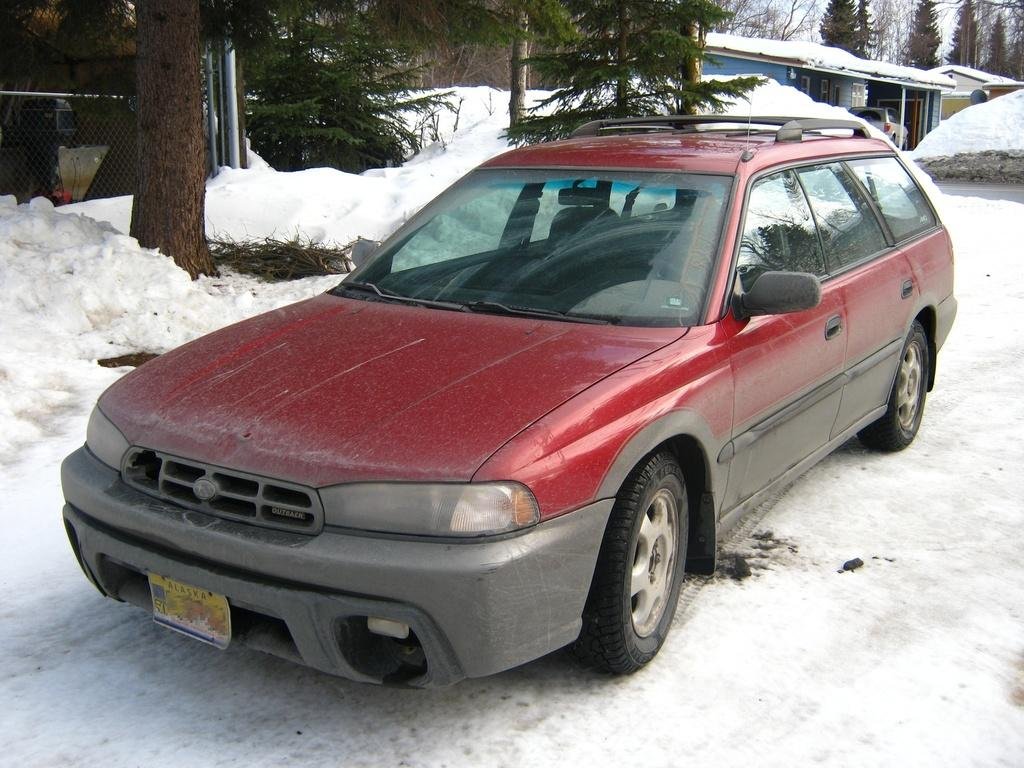What is the main subject in the foreground of the image? There is a car in the foreground of the image. What is the condition of the ground in the foreground? There is snow in the foreground of the image. What can be seen towards the left side of the image? There are trees and snow towards the left side of the image, as well as fencing. What can be seen towards the right side of the image? There are trees, a building, a car, snow, a road, and sky visible towards the right side of the image. What type of flesh can be seen hanging from the trees in the image? There is no flesh visible in the image; the trees are covered in snow. What river is flowing through the image? There is no river present in the image. 